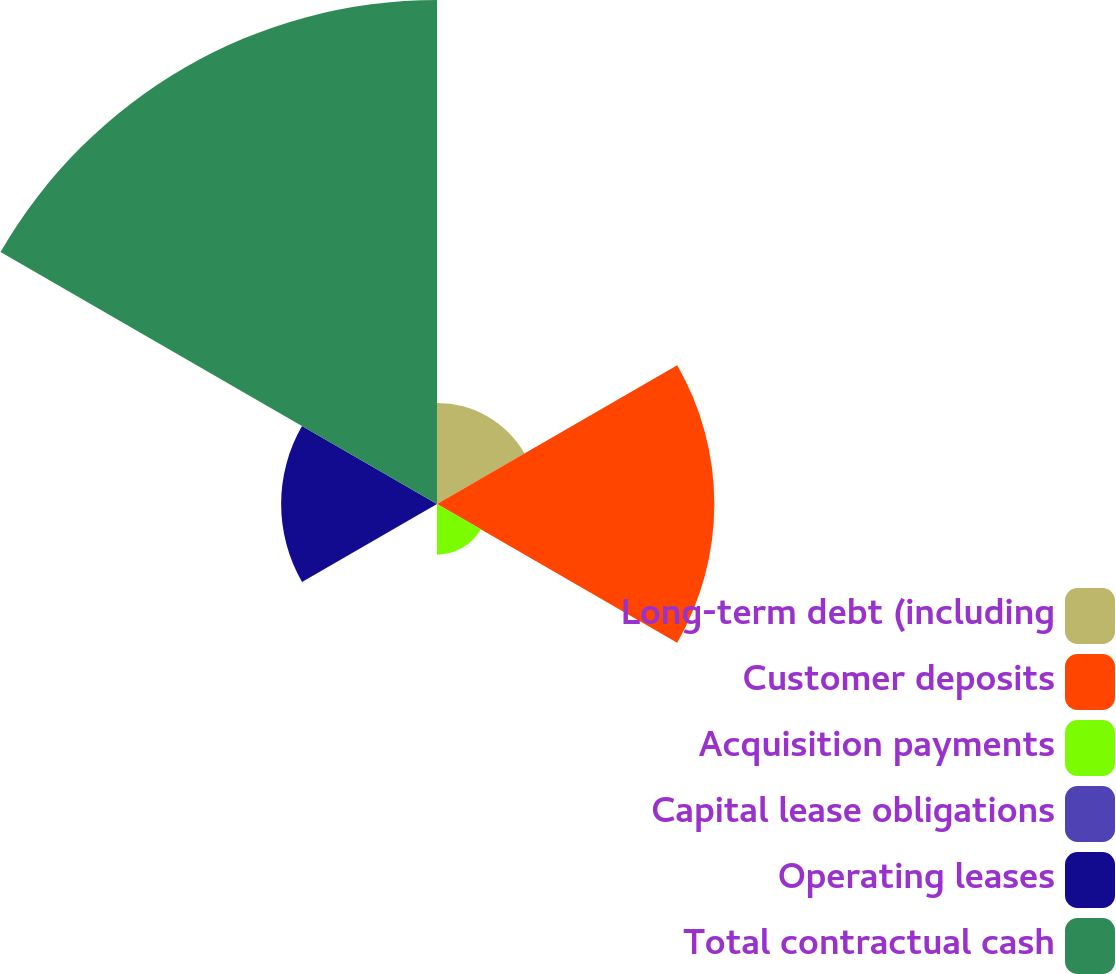<chart> <loc_0><loc_0><loc_500><loc_500><pie_chart><fcel>Long-term debt (including<fcel>Customer deposits<fcel>Acquisition payments<fcel>Capital lease obligations<fcel>Operating leases<fcel>Total contractual cash<nl><fcel>9.28%<fcel>25.46%<fcel>4.65%<fcel>0.03%<fcel>14.31%<fcel>46.27%<nl></chart> 